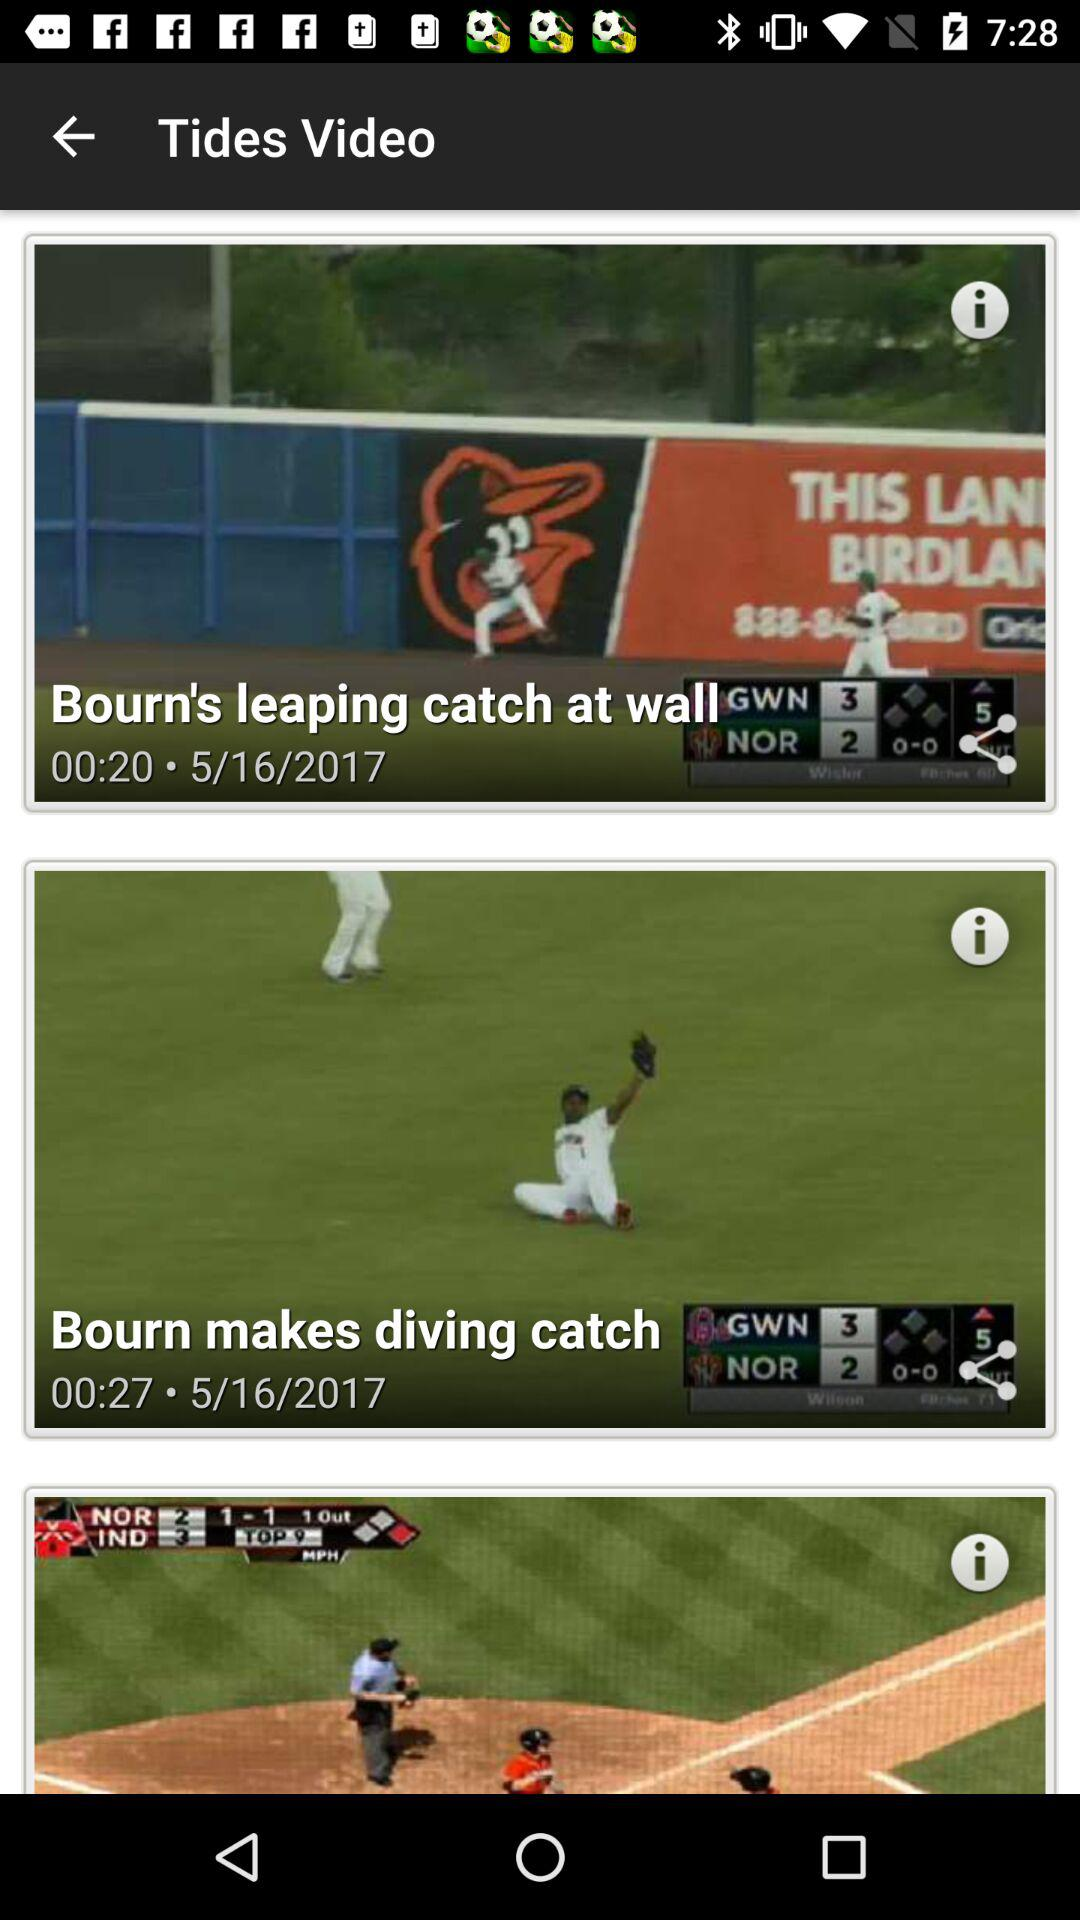How many videos are there in total?
Answer the question using a single word or phrase. 3 